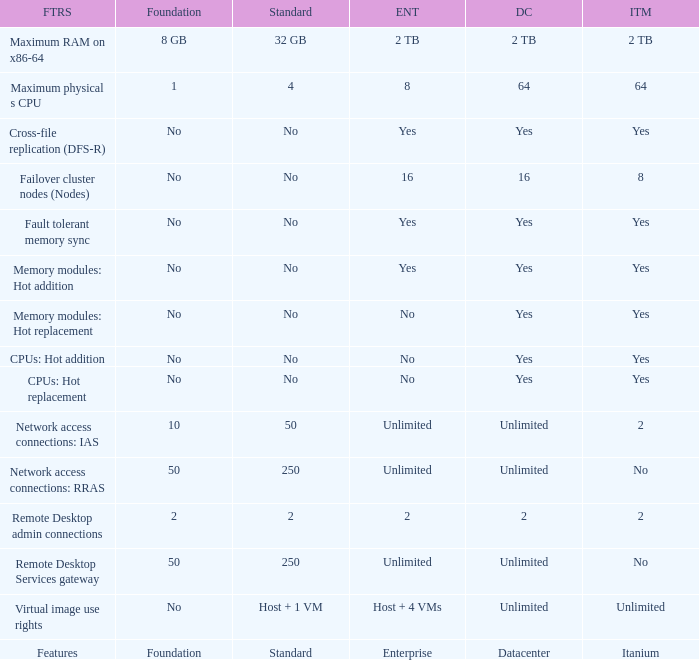What Datacenter is listed against the network access connections: rras Feature? Unlimited. 